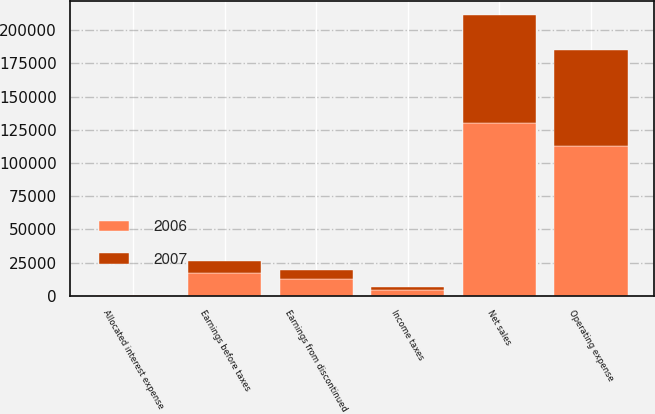<chart> <loc_0><loc_0><loc_500><loc_500><stacked_bar_chart><ecel><fcel>Net sales<fcel>Operating expense<fcel>Allocated interest expense<fcel>Earnings before taxes<fcel>Income taxes<fcel>Earnings from discontinued<nl><fcel>2007<fcel>81141<fcel>72239<fcel>351<fcel>8551<fcel>2279<fcel>6272<nl><fcel>2006<fcel>130348<fcel>112565<fcel>454<fcel>17329<fcel>4506<fcel>12823<nl></chart> 